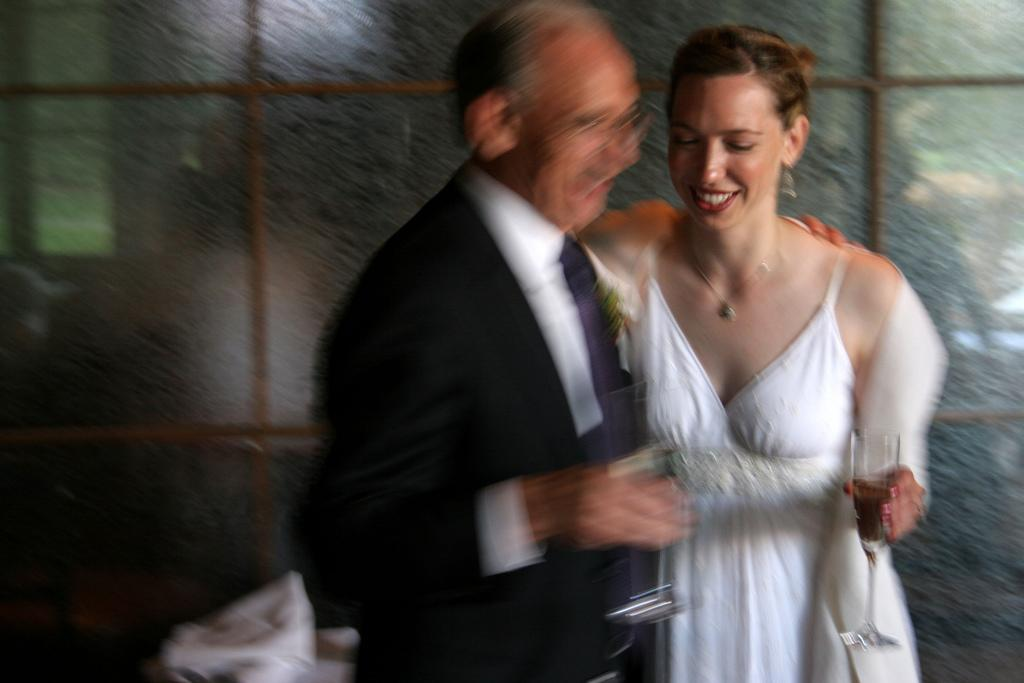How many people are in the image? There are two people in the image, a man and a woman. What are the man and woman doing in the image? The man and woman are standing and holding glasses. What can be seen in the background of the image? There is a glass window in the background of the image. What type of rice can be seen in the image? There is no rice present in the image. What type of ticket is the man holding in the image? The man is not holding a ticket in the image; he is holding a glass. 